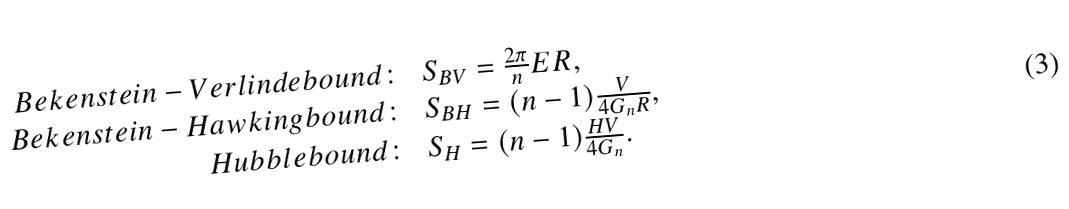<formula> <loc_0><loc_0><loc_500><loc_500>\begin{array} { r l } { B e k e n s t e i n - V e r l i n d e b o u n d \colon } & { { S _ { B V } = \frac { 2 \pi } { n } E R , } } \\ { B e k e n s t e i n - H a w k i n g b o u n d \colon } & { { S _ { B H } = ( n - 1 ) \frac { V } { 4 G _ { n } R } , } } \\ { H u b b l e b o u n d \colon } & { { S _ { H } = ( n - 1 ) \frac { H V } { 4 G _ { n } } . } } \end{array}</formula> 